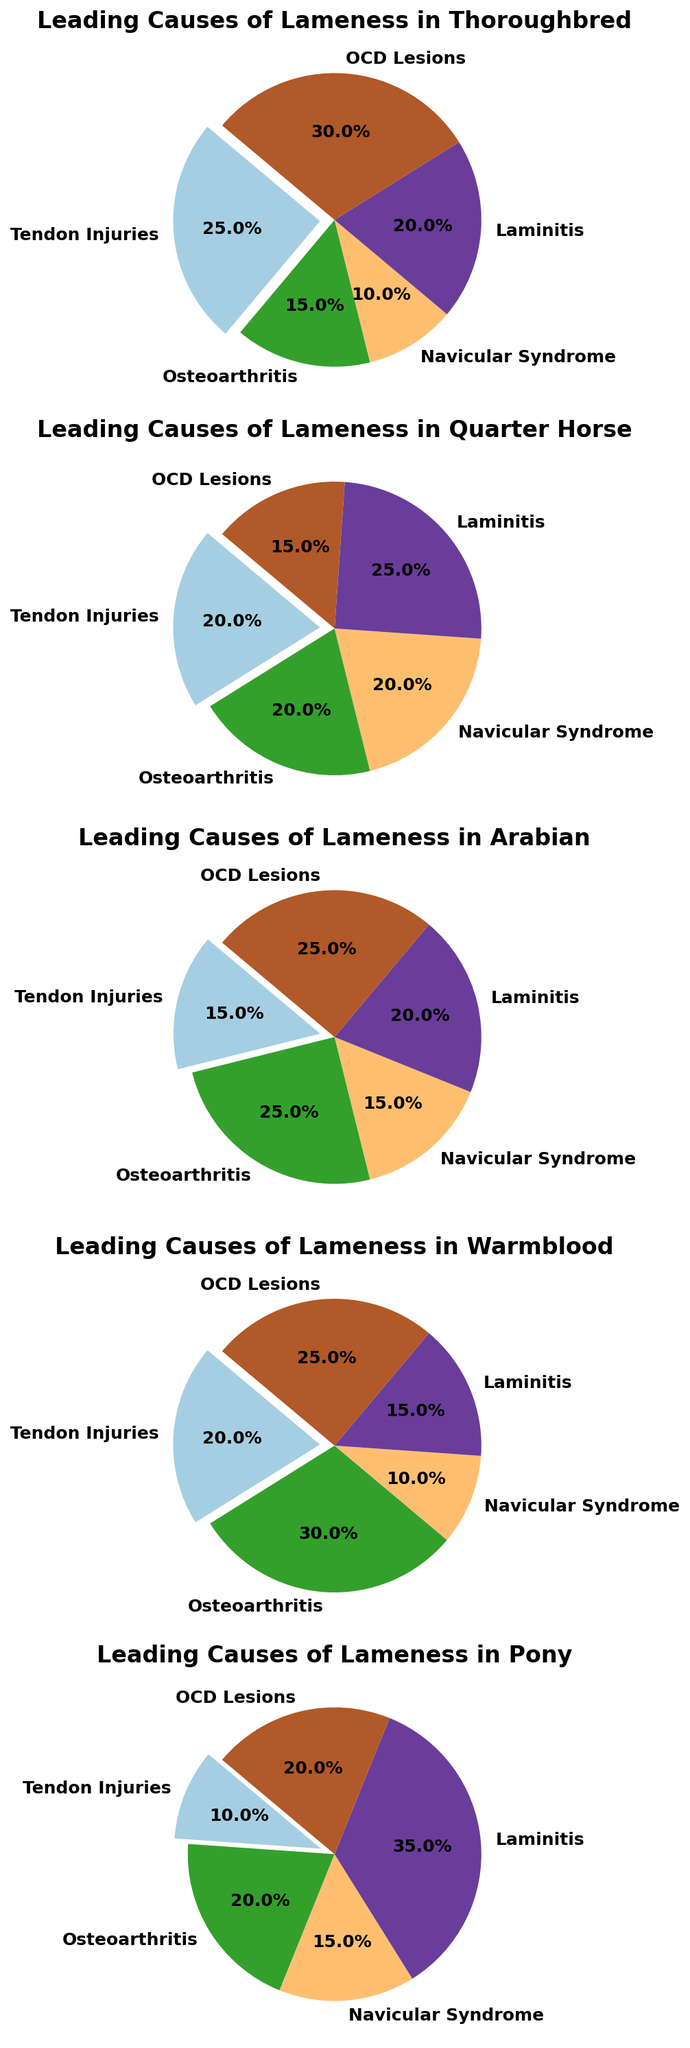Which breed has the highest percentage of OCD Lesions? Look at the section of the pie charts labeled "OCD Lesions" for each breed. The breed with the highest percentage is the answer. Here, Thoroughbred and Arabian both show 30% for OCD Lesions.
Answer: Thoroughbred, Arabian What is the difference in the percentage of Tendon Injuries between the Thoroughbred and the Pony? Find the percentage of Tendon Injuries in the pie charts for both the Thoroughbred (25%) and the Pony (10%). Subtract the Pony's percentage from the Thoroughbred's percentage: 25% - 10% = 15%.
Answer: 15% Which cause of lameness has the same percentage for Warmbloods and Ponies? Look at the slices of the pie charts for Warmbloods and Ponies. Identify if any slices have the same percentage for both breeds. Both have Navicular Syndrome at 10%.
Answer: Navicular Syndrome What is the combined percentage of Laminitis and Tendon Injuries for Quarter Horses? Locate the sections for Laminitis (25%) and Tendon Injuries (20%) in the pie chart for Quarter Horses. Add these percentages together: 25% + 20% = 45%.
Answer: 45% Which breed has the lowest percentage of Navicular Syndrome? Compare the "Navicular Syndrome" slices across all breeds. Warmbloods have the lowest percentage at 10%.
Answer: Warmblood What is the average percentage of Osteoarthritis across all breeds? Identify the Osteoarthritis percentages for all breeds: Thoroughbred (15%), Quarter Horse (20%), Arabian (25%), Warmblood (30%), and Pony (20%). Calculate the average: (15% + 20% + 25% + 30% + 20%) / 5 = 22%.
Answer: 22% What proportion of the pie chart for Arabians is due to Laminitis? Locate the Laminitis slice in the Arabian pie chart. It shows a percentage of 20%. This means 20% of the pie chart is due to Laminitis.
Answer: 20% Which breed has the largest pie chart slice for Laminitis? Compare the Laminitis slices across all the breeds. Ponies have the largest slice at 35%.
Answer: Pony Of the five causes of lameness shown, which one is the least common in Thoroughbreds? Look at the pie chart for Thoroughbreds and find the smallest slice. Navicular Syndrome has the smallest percentage at 10%.
Answer: Navicular Syndrome 